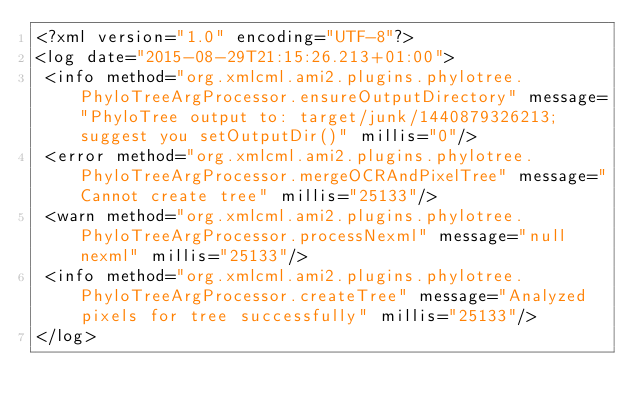<code> <loc_0><loc_0><loc_500><loc_500><_XML_><?xml version="1.0" encoding="UTF-8"?>
<log date="2015-08-29T21:15:26.213+01:00">
 <info method="org.xmlcml.ami2.plugins.phylotree.PhyloTreeArgProcessor.ensureOutputDirectory" message="PhyloTree output to: target/junk/1440879326213; suggest you setOutputDir()" millis="0"/>
 <error method="org.xmlcml.ami2.plugins.phylotree.PhyloTreeArgProcessor.mergeOCRAndPixelTree" message="Cannot create tree" millis="25133"/>
 <warn method="org.xmlcml.ami2.plugins.phylotree.PhyloTreeArgProcessor.processNexml" message="null nexml" millis="25133"/>
 <info method="org.xmlcml.ami2.plugins.phylotree.PhyloTreeArgProcessor.createTree" message="Analyzed pixels for tree successfully" millis="25133"/>
</log>
</code> 